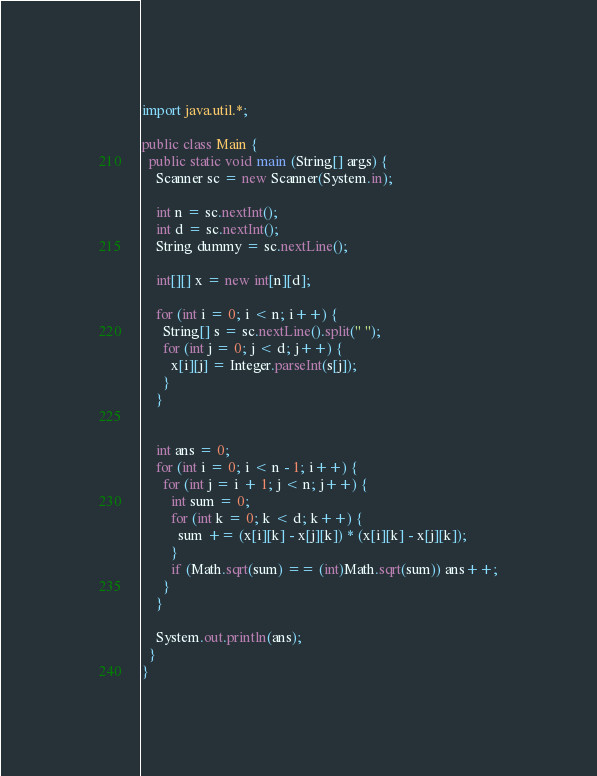<code> <loc_0><loc_0><loc_500><loc_500><_Java_>import java.util.*;

public class Main {
  public static void main (String[] args) {
    Scanner sc = new Scanner(System.in);

    int n = sc.nextInt();
    int d = sc.nextInt();
    String dummy = sc.nextLine();
    
    int[][] x = new int[n][d];

    for (int i = 0; i < n; i++) {
      String[] s = sc.nextLine().split(" ");
      for (int j = 0; j < d; j++) {
        x[i][j] = Integer.parseInt(s[j]);
      }
    }

    
    int ans = 0;
    for (int i = 0; i < n - 1; i++) {
      for (int j = i + 1; j < n; j++) {
        int sum = 0;
        for (int k = 0; k < d; k++) {
          sum += (x[i][k] - x[j][k]) * (x[i][k] - x[j][k]);
        }
        if (Math.sqrt(sum) == (int)Math.sqrt(sum)) ans++;
      }
    }

    System.out.println(ans);
  }
}
</code> 